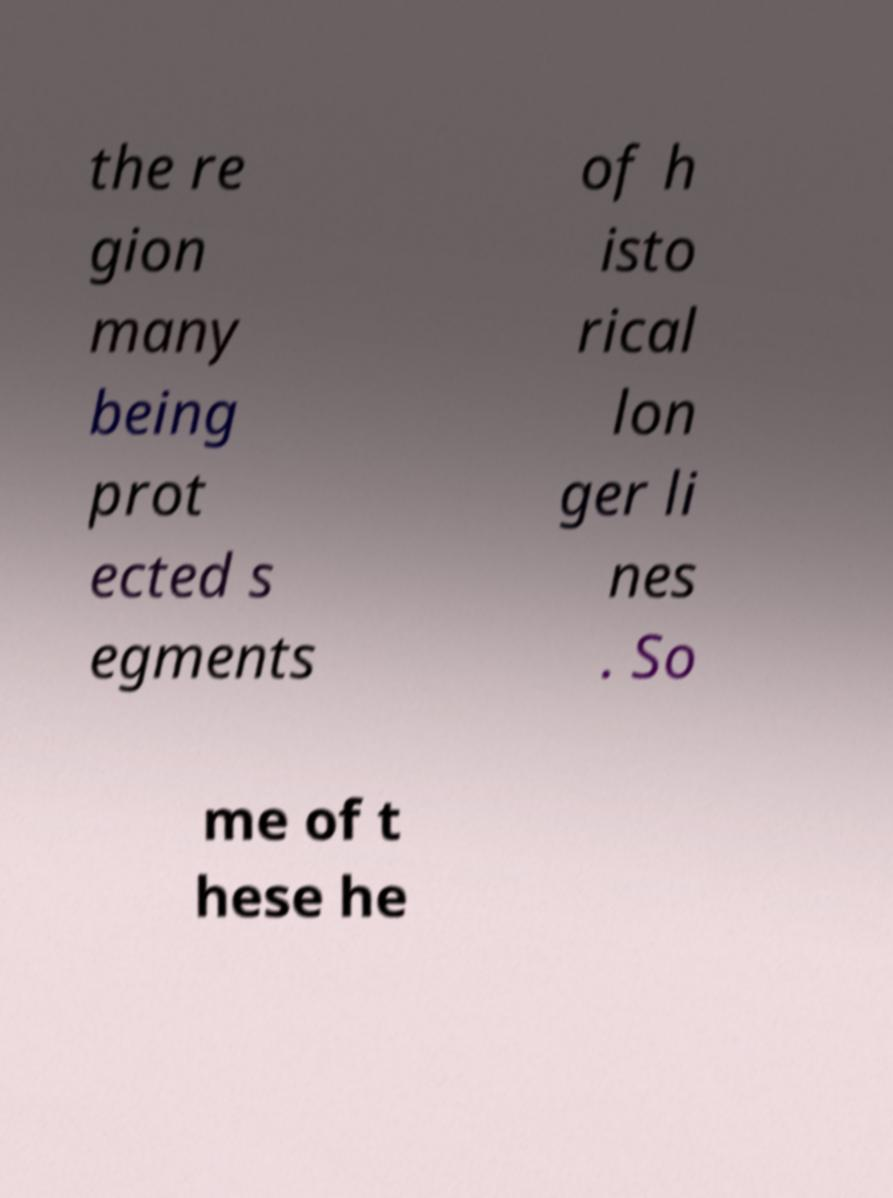Please read and relay the text visible in this image. What does it say? the re gion many being prot ected s egments of h isto rical lon ger li nes . So me of t hese he 